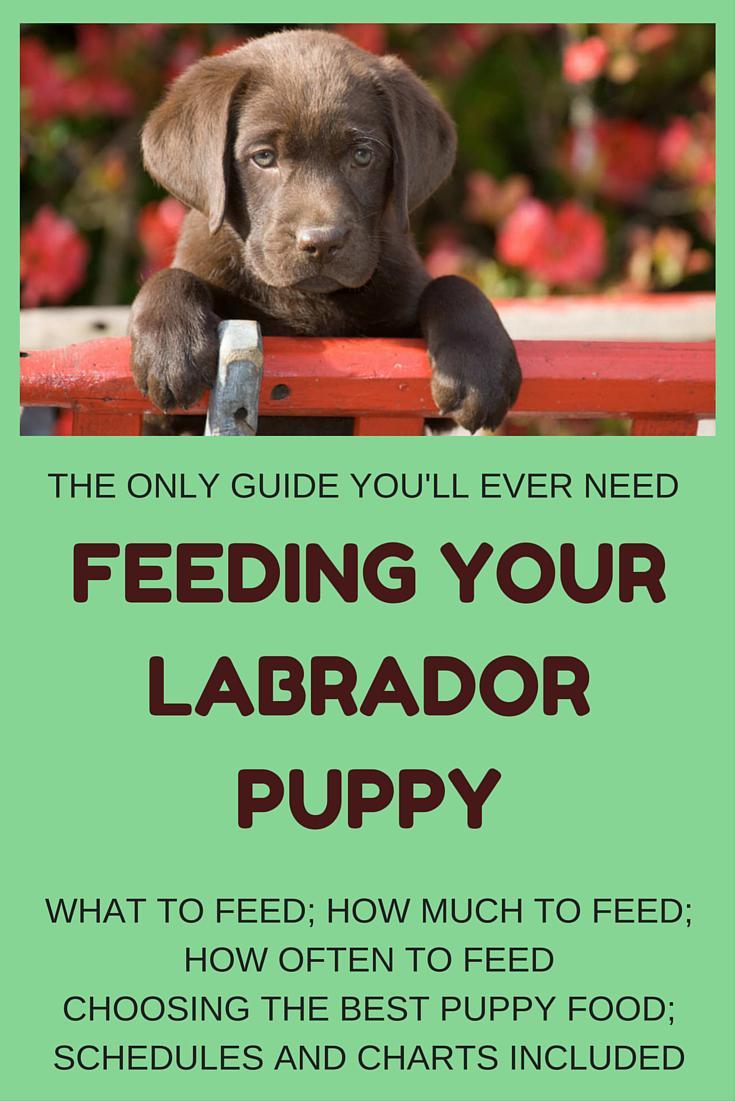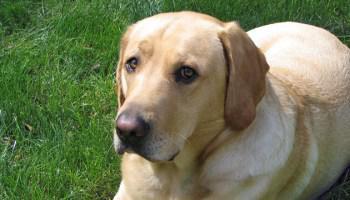The first image is the image on the left, the second image is the image on the right. For the images displayed, is the sentence "No more than 3 puppies are eating food from a bowl." factually correct? Answer yes or no. No. The first image is the image on the left, the second image is the image on the right. Considering the images on both sides, is "There are no more than four dogs." valid? Answer yes or no. Yes. 